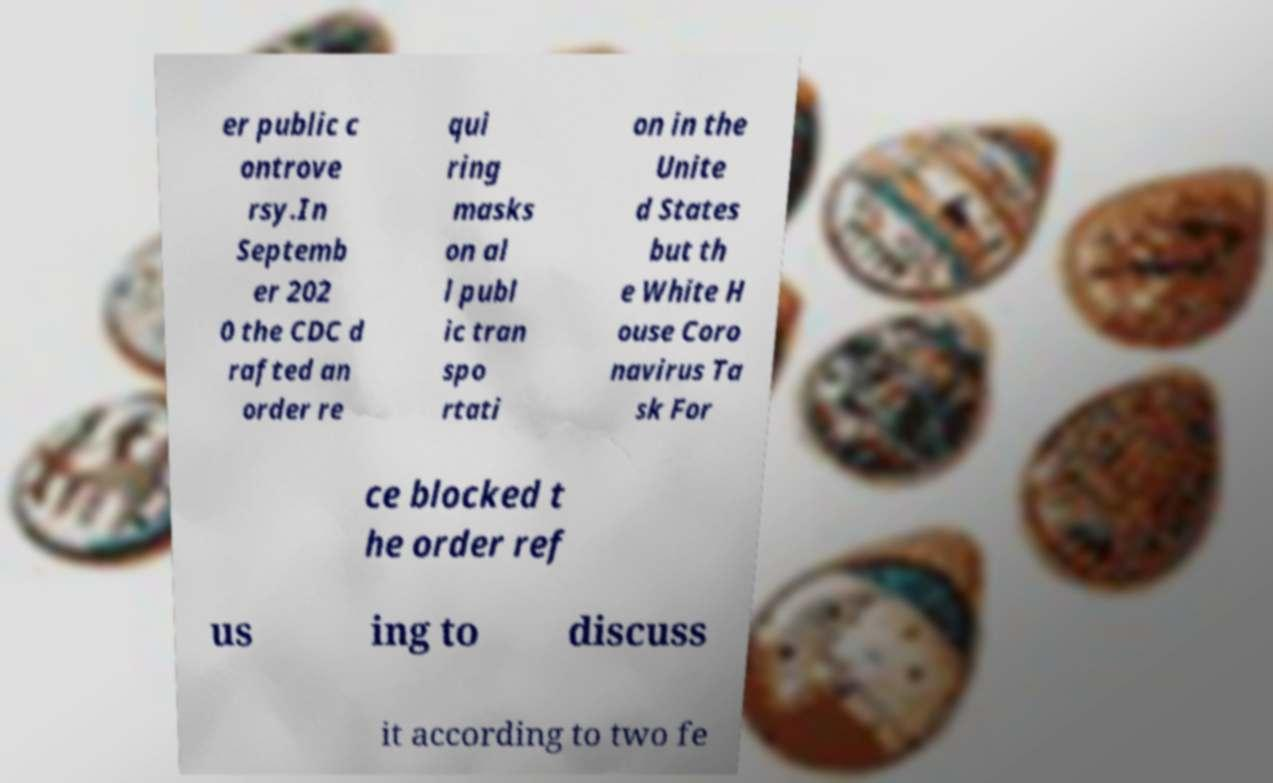Please identify and transcribe the text found in this image. er public c ontrove rsy.In Septemb er 202 0 the CDC d rafted an order re qui ring masks on al l publ ic tran spo rtati on in the Unite d States but th e White H ouse Coro navirus Ta sk For ce blocked t he order ref us ing to discuss it according to two fe 